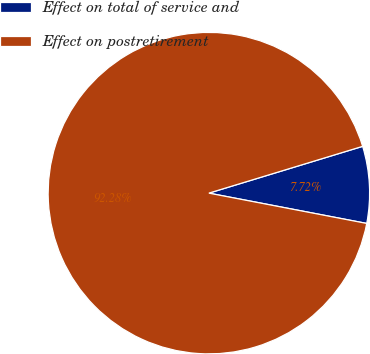Convert chart to OTSL. <chart><loc_0><loc_0><loc_500><loc_500><pie_chart><fcel>Effect on total of service and<fcel>Effect on postretirement<nl><fcel>7.72%<fcel>92.28%<nl></chart> 